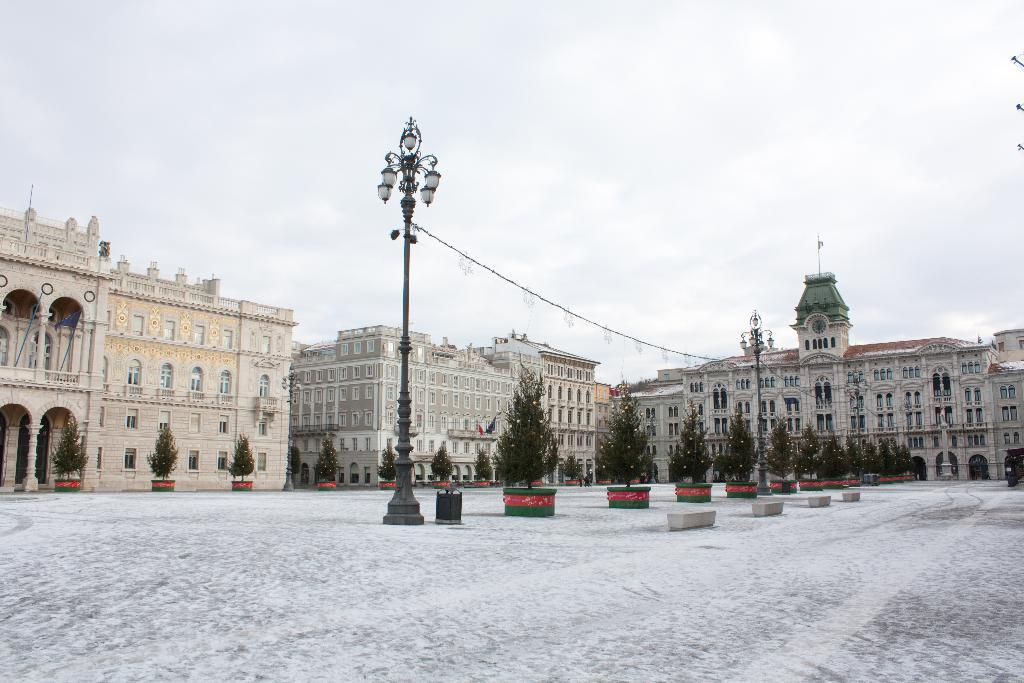What type of structures can be seen in the image? There are buildings in the image. What other natural elements are present in the image? There are trees in the image. Are there any artificial light sources visible in the image? Yes, there are street lights in the image. What can be seen in the background of the image? The sky is visible in the background of the image. Where is the nest located in the image? There is no nest present in the image. How many children are playing in the image? There is no reference to children in the image, so it is not possible to determine their presence or number. 